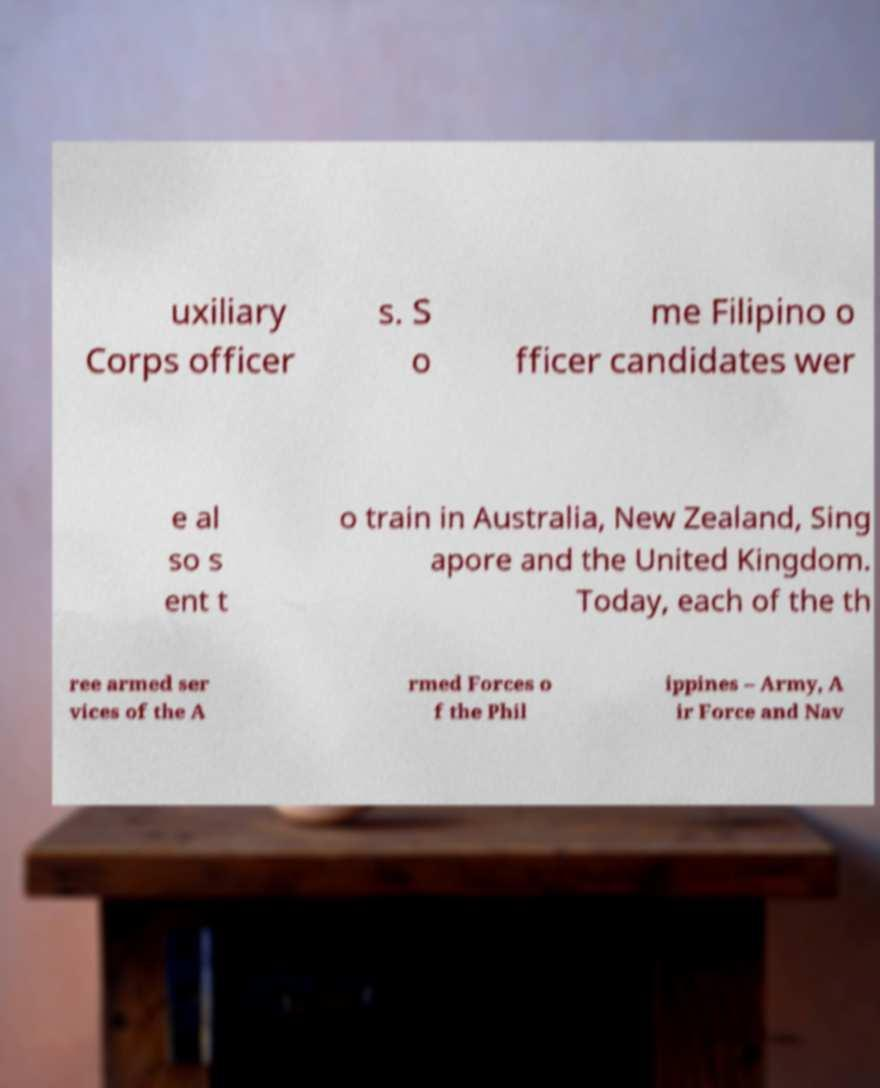For documentation purposes, I need the text within this image transcribed. Could you provide that? uxiliary Corps officer s. S o me Filipino o fficer candidates wer e al so s ent t o train in Australia, New Zealand, Sing apore and the United Kingdom. Today, each of the th ree armed ser vices of the A rmed Forces o f the Phil ippines – Army, A ir Force and Nav 